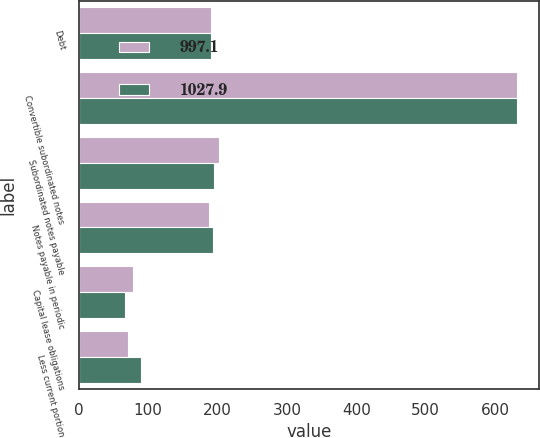<chart> <loc_0><loc_0><loc_500><loc_500><stacked_bar_chart><ecel><fcel>Debt<fcel>Convertible subordinated notes<fcel>Subordinated notes payable<fcel>Notes payable in periodic<fcel>Capital lease obligations<fcel>Less current portion<nl><fcel>997.1<fcel>190<fcel>632.1<fcel>201.5<fcel>187.1<fcel>77.8<fcel>70.6<nl><fcel>1027.9<fcel>190<fcel>632.5<fcel>194.2<fcel>192.9<fcel>66.4<fcel>88.9<nl></chart> 